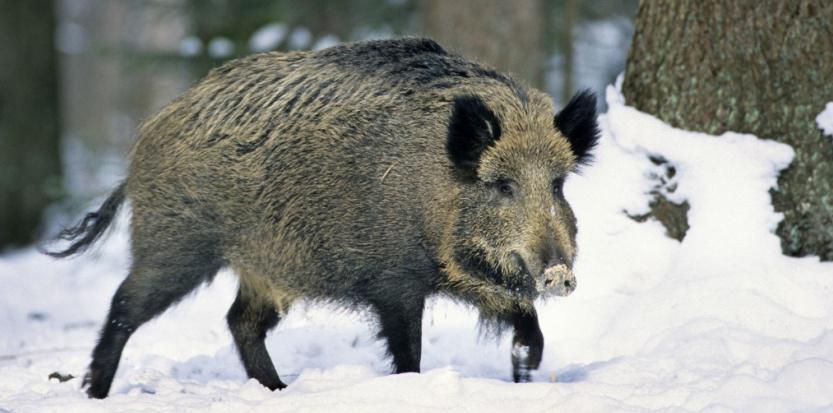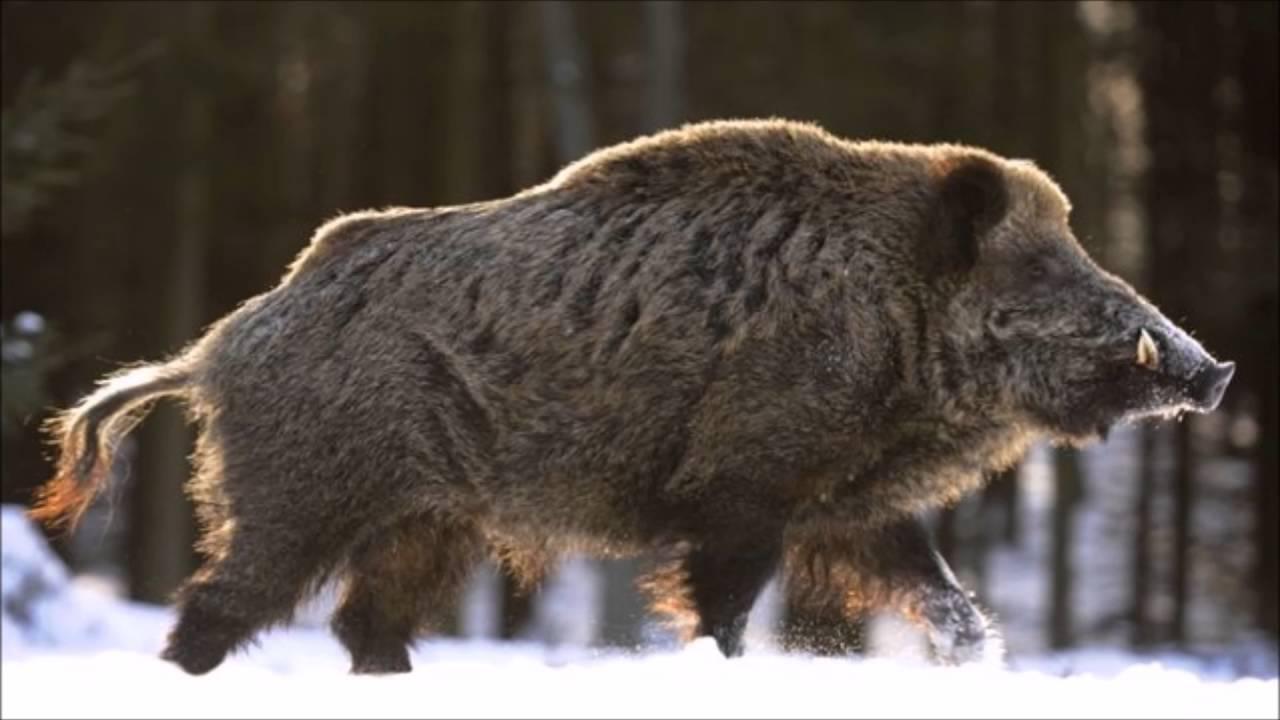The first image is the image on the left, the second image is the image on the right. Considering the images on both sides, is "In one image the ground is not covered in snow." valid? Answer yes or no. No. 